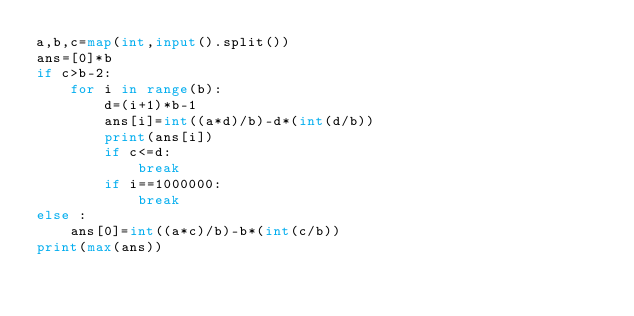Convert code to text. <code><loc_0><loc_0><loc_500><loc_500><_Python_>a,b,c=map(int,input().split())
ans=[0]*b
if c>b-2:
    for i in range(b):
        d=(i+1)*b-1
        ans[i]=int((a*d)/b)-d*(int(d/b))
        print(ans[i])
        if c<=d:
            break
        if i==1000000:
            break
else :
    ans[0]=int((a*c)/b)-b*(int(c/b))
print(max(ans))</code> 